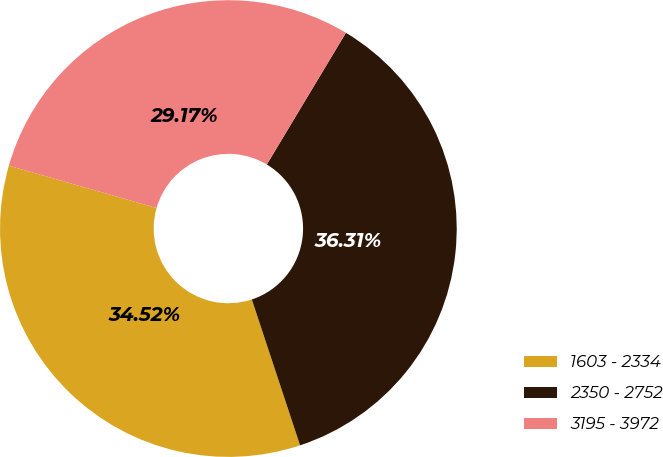<chart> <loc_0><loc_0><loc_500><loc_500><pie_chart><fcel>1603 - 2334<fcel>2350 - 2752<fcel>3195 - 3972<nl><fcel>34.52%<fcel>36.31%<fcel>29.17%<nl></chart> 